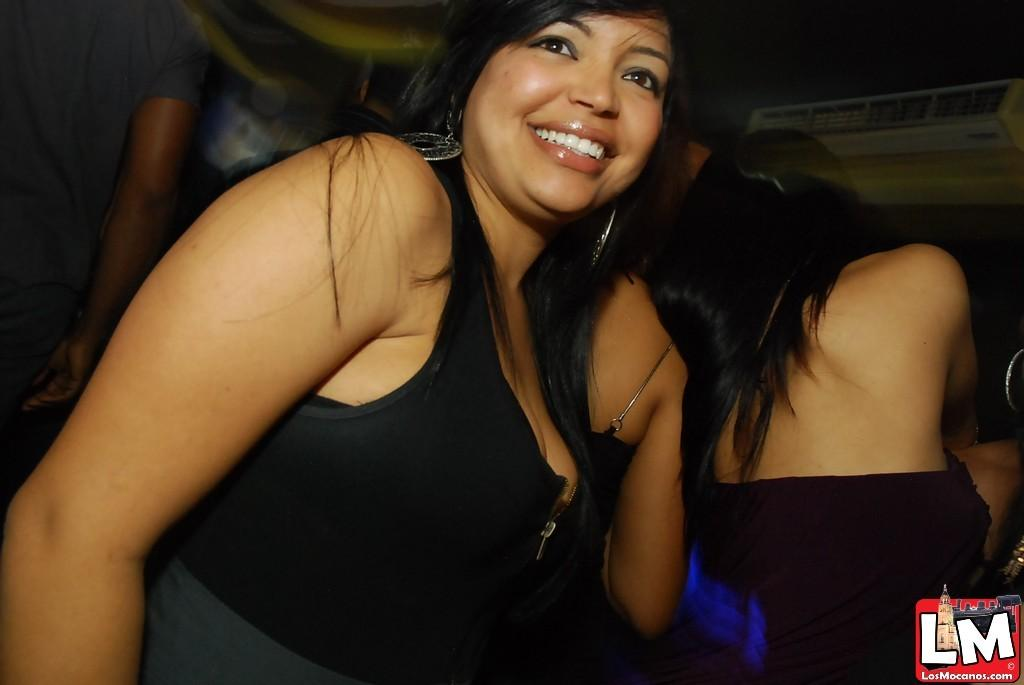<image>
Summarize the visual content of the image. A woman in night club attire and a sticker that reads "LM Los Mocanos" 